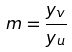Convert formula to latex. <formula><loc_0><loc_0><loc_500><loc_500>m = \frac { y _ { v } } { y _ { u } }</formula> 